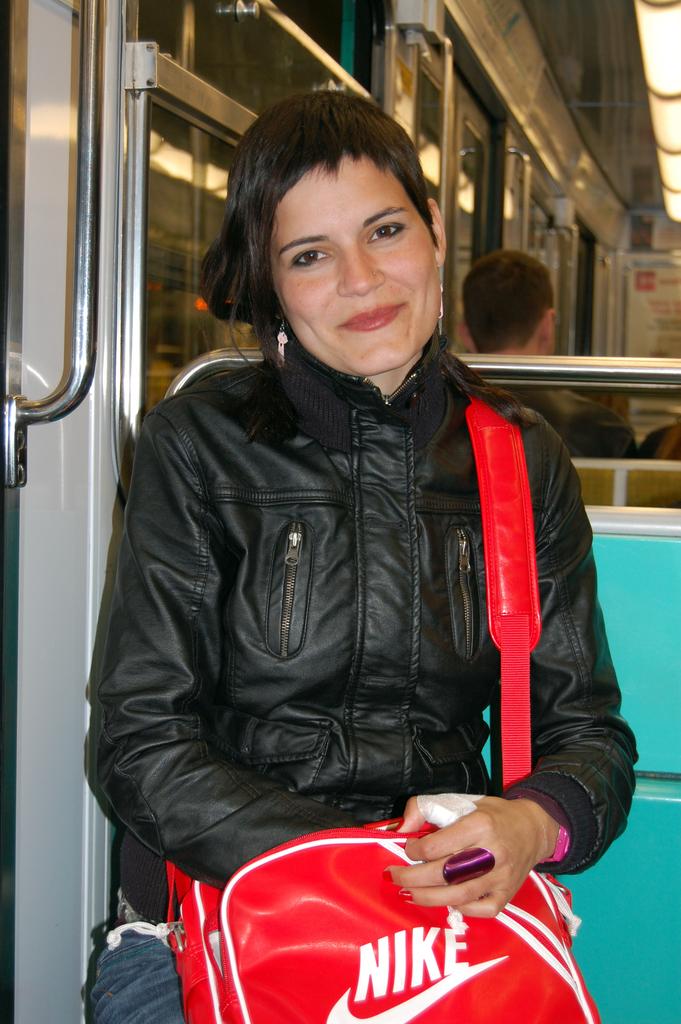What brand bag is held?
Offer a terse response. Nike. What is the third letter on the bag?
Offer a terse response. K. 